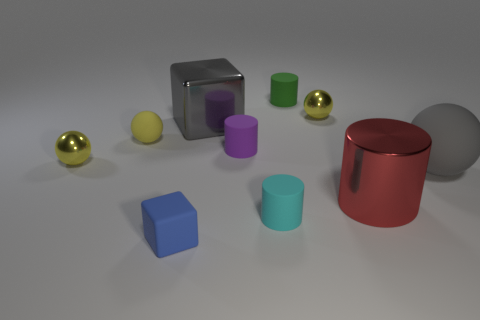Is the number of blue matte cubes that are right of the big gray matte thing greater than the number of big red cylinders in front of the shiny cylinder?
Make the answer very short. No. There is a small metal object on the left side of the yellow metallic thing right of the green cylinder; what is its color?
Offer a terse response. Yellow. Do the large cylinder and the green cylinder have the same material?
Offer a very short reply. No. Is there a big matte object of the same shape as the small purple thing?
Keep it short and to the point. No. There is a tiny shiny sphere that is in front of the gray shiny cube; is its color the same as the tiny block?
Provide a short and direct response. No. There is a metallic thing that is on the left side of the blue block; does it have the same size as the block in front of the gray block?
Your answer should be very brief. Yes. What is the size of the block that is made of the same material as the big cylinder?
Give a very brief answer. Large. What number of blocks are in front of the small matte ball and behind the tiny cyan cylinder?
Provide a succinct answer. 0. What number of things are large blue cylinders or spheres to the left of the red thing?
Make the answer very short. 3. There is a large thing that is the same color as the large cube; what shape is it?
Provide a short and direct response. Sphere. 